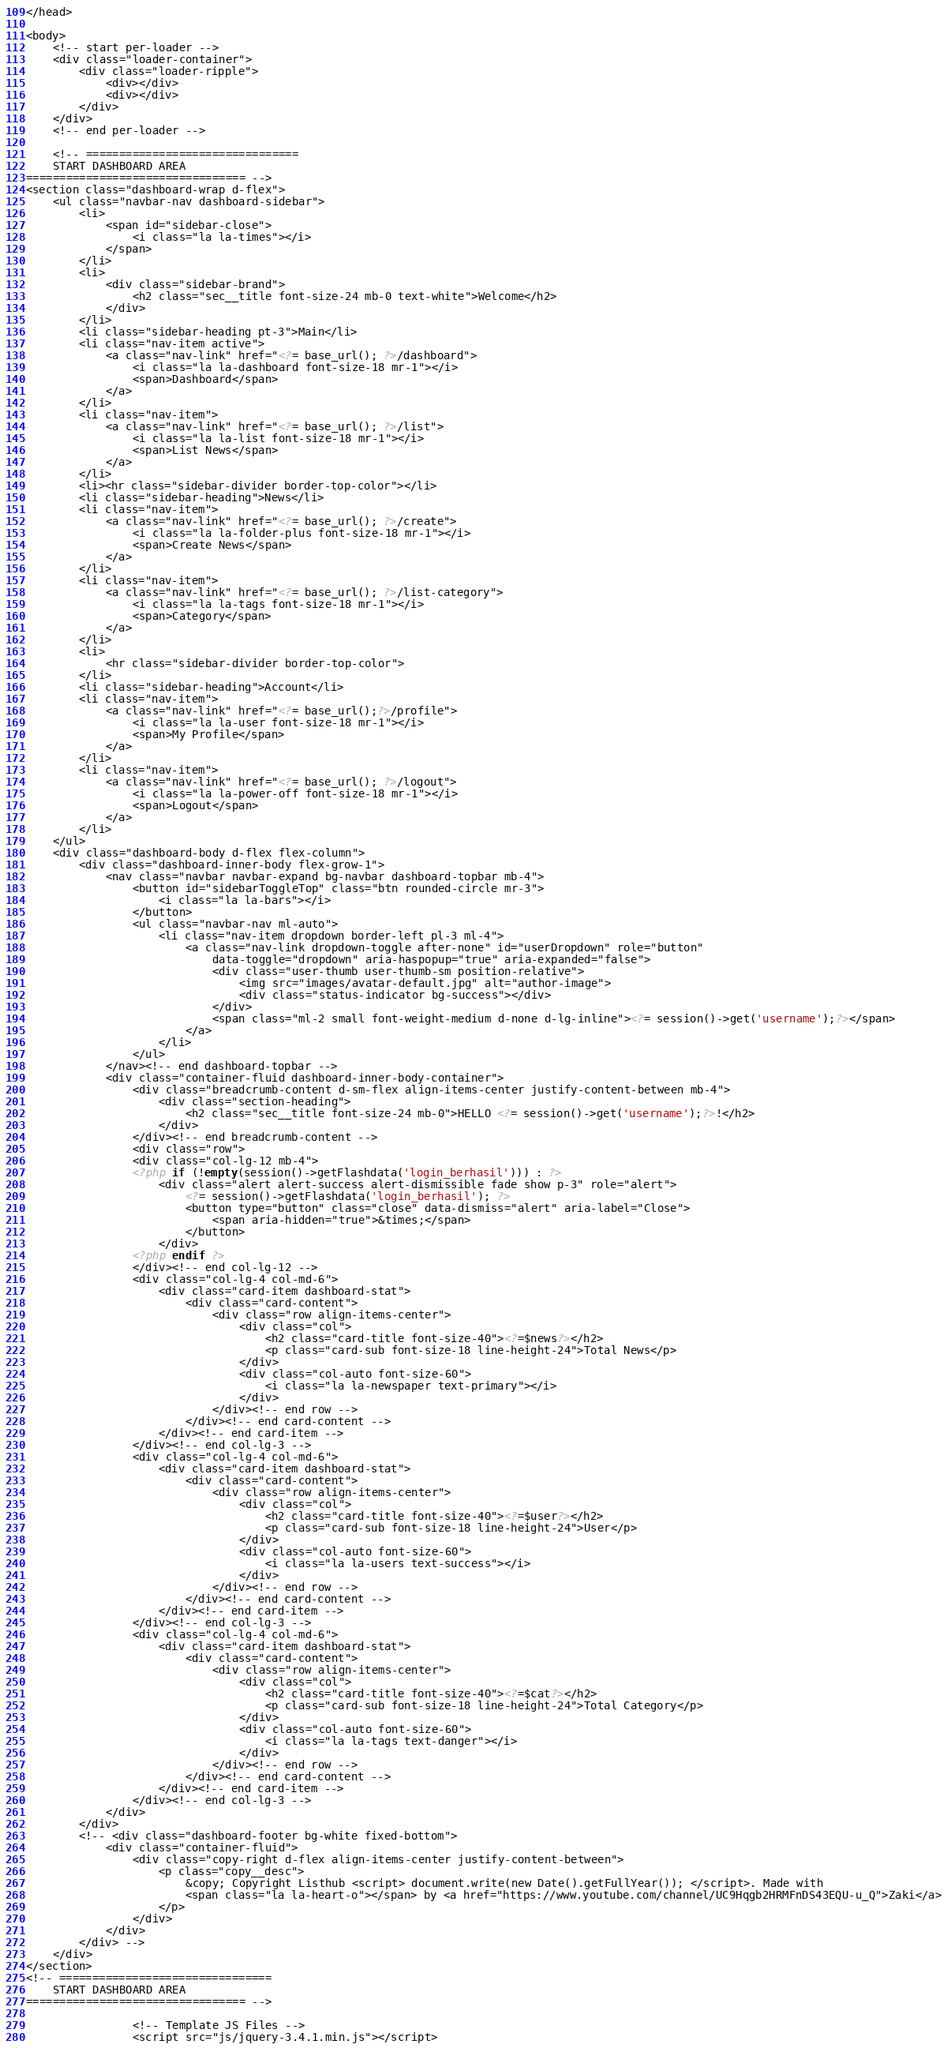<code> <loc_0><loc_0><loc_500><loc_500><_PHP_></head>

<body>
    <!-- start per-loader -->
    <div class="loader-container">
        <div class="loader-ripple">
            <div></div>
            <div></div>
        </div>
    </div>
    <!-- end per-loader -->

    <!-- ================================
    START DASHBOARD AREA
================================= -->
<section class="dashboard-wrap d-flex">
    <ul class="navbar-nav dashboard-sidebar">
        <li>
            <span id="sidebar-close">
                <i class="la la-times"></i>
            </span>
        </li>
        <li>
            <div class="sidebar-brand">
                <h2 class="sec__title font-size-24 mb-0 text-white">Welcome</h2>
            </div>
        </li>
        <li class="sidebar-heading pt-3">Main</li>
        <li class="nav-item active">
            <a class="nav-link" href="<?= base_url(); ?>/dashboard">
                <i class="la la-dashboard font-size-18 mr-1"></i>
                <span>Dashboard</span>
            </a>
        </li>
        <li class="nav-item">
            <a class="nav-link" href="<?= base_url(); ?>/list">
                <i class="la la-list font-size-18 mr-1"></i>
                <span>List News</span>
            </a>
        </li>
        <li><hr class="sidebar-divider border-top-color"></li>
        <li class="sidebar-heading">News</li>
        <li class="nav-item">
            <a class="nav-link" href="<?= base_url(); ?>/create">
                <i class="la la-folder-plus font-size-18 mr-1"></i>
                <span>Create News</span>
            </a>
        </li>
        <li class="nav-item">
            <a class="nav-link" href="<?= base_url(); ?>/list-category">
                <i class="la la-tags font-size-18 mr-1"></i>
                <span>Category</span>
            </a>
        </li>
        <li>
            <hr class="sidebar-divider border-top-color">
        </li>
        <li class="sidebar-heading">Account</li>
        <li class="nav-item">
            <a class="nav-link" href="<?= base_url();?>/profile">
                <i class="la la-user font-size-18 mr-1"></i>
                <span>My Profile</span>
            </a>
        </li>
        <li class="nav-item">
            <a class="nav-link" href="<?= base_url(); ?>/logout">
                <i class="la la-power-off font-size-18 mr-1"></i>
                <span>Logout</span>
            </a>
        </li>
    </ul>
    <div class="dashboard-body d-flex flex-column">
        <div class="dashboard-inner-body flex-grow-1">
            <nav class="navbar navbar-expand bg-navbar dashboard-topbar mb-4">
                <button id="sidebarToggleTop" class="btn rounded-circle mr-3">
                    <i class="la la-bars"></i>
                </button>
                <ul class="navbar-nav ml-auto">
                    <li class="nav-item dropdown border-left pl-3 ml-4">
                        <a class="nav-link dropdown-toggle after-none" id="userDropdown" role="button"
                            data-toggle="dropdown" aria-haspopup="true" aria-expanded="false">
                            <div class="user-thumb user-thumb-sm position-relative">
                                <img src="images/avatar-default.jpg" alt="author-image">
                                <div class="status-indicator bg-success"></div>
                            </div>
                            <span class="ml-2 small font-weight-medium d-none d-lg-inline"><?= session()->get('username');?></span>
                        </a>
                    </li>
                </ul>
            </nav><!-- end dashboard-topbar -->
            <div class="container-fluid dashboard-inner-body-container">
                <div class="breadcrumb-content d-sm-flex align-items-center justify-content-between mb-4">
                    <div class="section-heading">
                        <h2 class="sec__title font-size-24 mb-0">HELLO <?= session()->get('username');?>!</h2>
                    </div>
                </div><!-- end breadcrumb-content -->
                <div class="row">
                <div class="col-lg-12 mb-4">
                <?php if (!empty(session()->getFlashdata('login_berhasil'))) : ?>
                    <div class="alert alert-success alert-dismissible fade show p-3" role="alert">
                        <?= session()->getFlashdata('login_berhasil'); ?>
                        <button type="button" class="close" data-dismiss="alert" aria-label="Close">
                            <span aria-hidden="true">&times;</span>
                        </button>
                    </div>
                <?php endif ?>
                </div><!-- end col-lg-12 -->
                <div class="col-lg-4 col-md-6">
                    <div class="card-item dashboard-stat">
                        <div class="card-content">
                            <div class="row align-items-center">
                                <div class="col">
                                    <h2 class="card-title font-size-40"><?=$news?></h2>
                                    <p class="card-sub font-size-18 line-height-24">Total News</p>
                                </div>
                                <div class="col-auto font-size-60">
                                    <i class="la la-newspaper text-primary"></i>
                                </div>
                            </div><!-- end row -->
                        </div><!-- end card-content -->
                    </div><!-- end card-item -->
                </div><!-- end col-lg-3 -->
                <div class="col-lg-4 col-md-6">
                    <div class="card-item dashboard-stat">
                        <div class="card-content">
                            <div class="row align-items-center">
                                <div class="col">
                                    <h2 class="card-title font-size-40"><?=$user?></h2>
                                    <p class="card-sub font-size-18 line-height-24">User</p>
                                </div>
                                <div class="col-auto font-size-60">
                                    <i class="la la-users text-success"></i>
                                </div>
                            </div><!-- end row -->
                        </div><!-- end card-content -->
                    </div><!-- end card-item -->
                </div><!-- end col-lg-3 -->
                <div class="col-lg-4 col-md-6">
                    <div class="card-item dashboard-stat">
                        <div class="card-content">
                            <div class="row align-items-center">
                                <div class="col">
                                    <h2 class="card-title font-size-40"><?=$cat?></h2>
                                    <p class="card-sub font-size-18 line-height-24">Total Category</p>
                                </div>
                                <div class="col-auto font-size-60">
                                    <i class="la la-tags text-danger"></i>
                                </div>
                            </div><!-- end row -->
                        </div><!-- end card-content -->
                    </div><!-- end card-item -->
                </div><!-- end col-lg-3 -->
            </div>
        </div>
        <!-- <div class="dashboard-footer bg-white fixed-bottom">
            <div class="container-fluid">
                <div class="copy-right d-flex align-items-center justify-content-between">
                    <p class="copy__desc">
                        &copy; Copyright Listhub <script> document.write(new Date().getFullYear()); </script>. Made with
                        <span class="la la-heart-o"></span> by <a href="https://www.youtube.com/channel/UC9Hqgb2HRMFnDS43EQU-u_Q">Zaki</a>
                    </p>
                </div>
            </div>
        </div> -->
    </div>   
</section>
<!-- ================================
    START DASHBOARD AREA
================================= -->

                <!-- Template JS Files -->
                <script src="js/jquery-3.4.1.min.js"></script></code> 